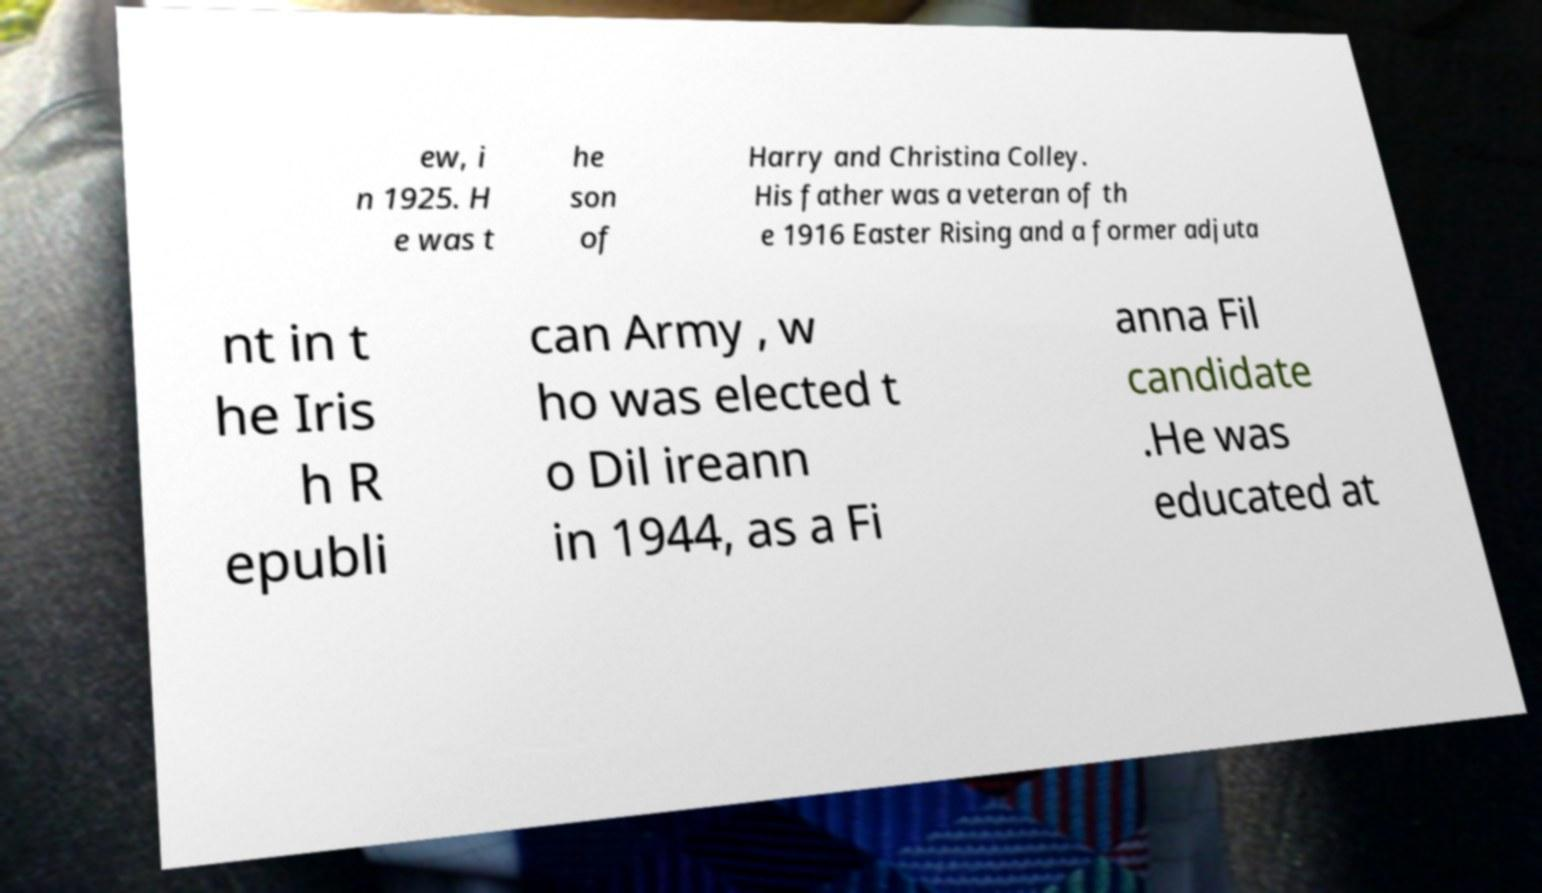For documentation purposes, I need the text within this image transcribed. Could you provide that? ew, i n 1925. H e was t he son of Harry and Christina Colley. His father was a veteran of th e 1916 Easter Rising and a former adjuta nt in t he Iris h R epubli can Army , w ho was elected t o Dil ireann in 1944, as a Fi anna Fil candidate .He was educated at 